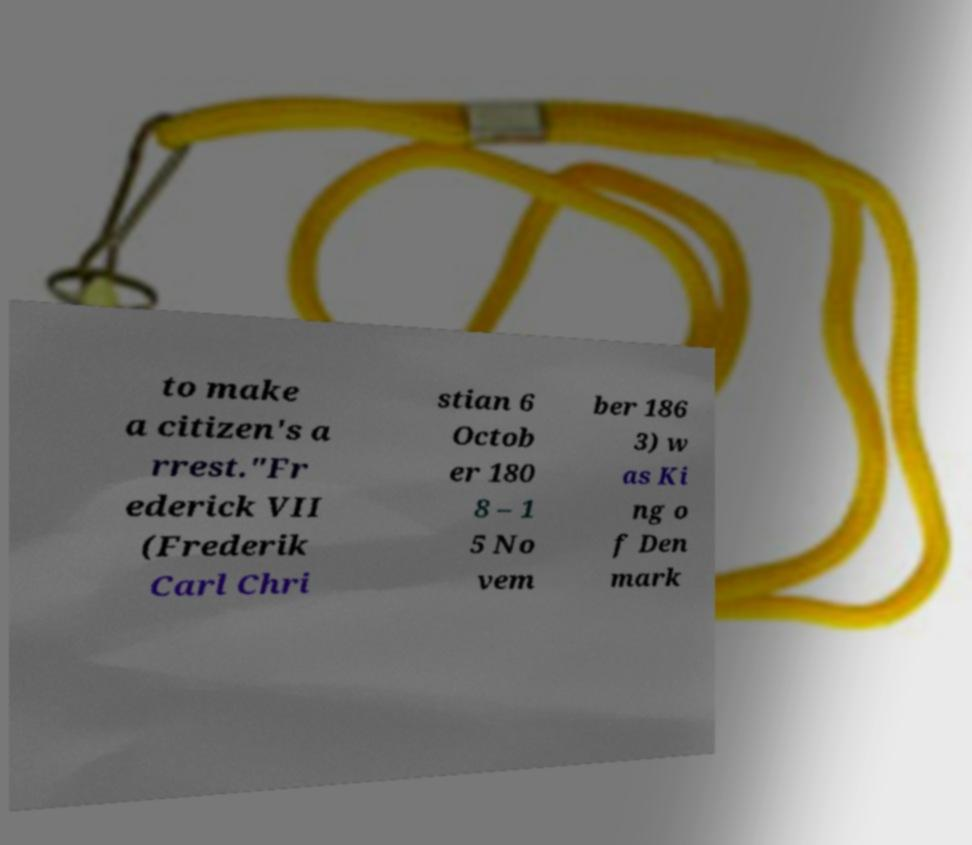Could you extract and type out the text from this image? to make a citizen's a rrest."Fr ederick VII (Frederik Carl Chri stian 6 Octob er 180 8 – 1 5 No vem ber 186 3) w as Ki ng o f Den mark 